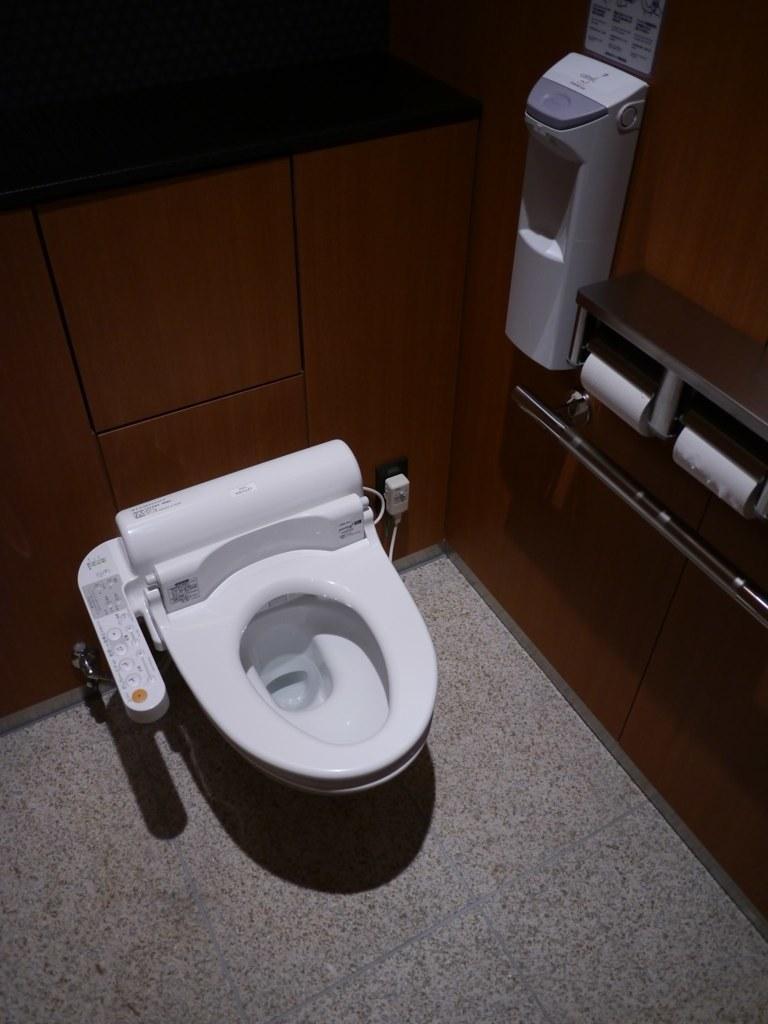Could you give a brief overview of what you see in this image? In the middle of the picture, we see a toilet seat. On the right side, we see the tissue rolls and a sanitizer. Behind that, we see a wall in brown color. In the background, we see a brown wall. This picture might be clicked in the washroom. 